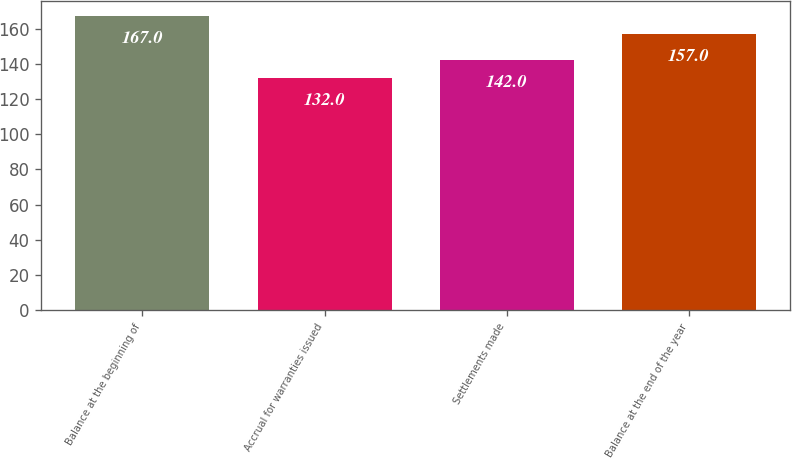<chart> <loc_0><loc_0><loc_500><loc_500><bar_chart><fcel>Balance at the beginning of<fcel>Accrual for warranties issued<fcel>Settlements made<fcel>Balance at the end of the year<nl><fcel>167<fcel>132<fcel>142<fcel>157<nl></chart> 